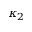Convert formula to latex. <formula><loc_0><loc_0><loc_500><loc_500>\kappa _ { 2 }</formula> 